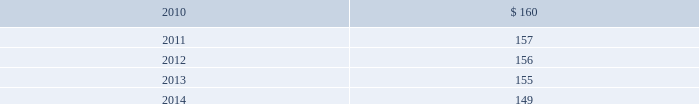Blackrock n 96 n notes in april 2009 , the company acquired $ 2 million of finite- lived management contracts with a five-year estimated useful life associated with the acquisition of the r3 capital partners funds .
In december 2009 , in conjunction with the bgi trans- action , the company acquired $ 163 million of finite- lived management contracts with a weighted-average estimated useful life of approximately 10 years .
Estimated amortization expense for finite-lived intangible assets for each of the five succeeding years is as follows : ( dollar amounts in millions ) .
Indefinite-lived acquired management contracts on september 29 , 2006 , in conjunction with the mlim transaction , the company acquired indefinite-lived man- agement contracts valued at $ 4477 million consisting of $ 4271 million for all retail mutual funds and $ 206 million for alternative investment products .
On october 1 , 2007 , in conjunction with the quellos transaction , the company acquired $ 631 million in indefinite-lived management contracts associated with alternative investment products .
On october 1 , 2007 , the company purchased the remain- ing 20% ( 20 % ) of an investment manager of a fund of hedge funds .
In conjunction with this transaction , the company recorded $ 8 million in additional indefinite-lived management contracts associated with alternative investment products .
On december 1 , 2009 , in conjunction with the bgi transaction , the company acquired $ 9785 million in indefinite-lived management contracts valued consisting primarily for exchange traded funds and common and collective trusts .
Indefinite-lived acquired trade names/trademarks on december 1 , 2009 , in conjunction with the bgi transaction , the company acquired trade names/ trademarks primarily related to ishares valued at $ 1402.5 million .
The fair value was determined using a royalty rate based primarily on normalized marketing and promotion expenditures to develop and support the brands globally .
13 .
Borrowings short-term borrowings 2007 facility in august 2007 , the company entered into a five-year $ 2.5 billion unsecured revolving credit facility ( the 201c2007 facility 201d ) , which permits the company to request an additional $ 500 million of borrowing capacity , subject to lender credit approval , up to a maximum of $ 3.0 billion .
The 2007 facility requires the company not to exceed a maximum leverage ratio ( ratio of net debt to earnings before interest , taxes , depreciation and amortiza- tion , where net debt equals total debt less domestic unrestricted cash ) of 3 to 1 , which was satisfied with a ratio of less than 1 to 1 at december 31 , 2009 .
The 2007 facility provides back-up liquidity , funds ongoing working capital for general corporate purposes and funds various investment opportunities .
At december 31 , 2009 , the company had $ 200 million outstanding under the 2007 facility with an interest rate of 0.44% ( 0.44 % ) and a maturity date during february 2010 .
During february 2010 , the company rolled over $ 100 million in borrowings with an interest rate of 0.43% ( 0.43 % ) and a maturity date in may 2010 .
Lehman commercial paper inc .
Has a $ 140 million participation under the 2007 facility ; however blackrock does not expect that lehman commercial paper inc .
Will honor its commitment to fund additional amounts .
Bank of america , a related party , has a $ 140 million participation under the 2007 facility .
In december 2007 , in order to support two enhanced cash funds that blackrock manages , blackrock elected to procure two letters of credit under the existing 2007 facility in an aggregate amount of $ 100 million .
In decem- ber 2008 , the letters of credit were terminated .
Commercial paper program on october 14 , 2009 , blackrock established a com- mercial paper program ( the 201ccp program 201d ) under which the company may issue unsecured commercial paper notes ( the 201ccp notes 201d ) on a private placement basis up to a maximum aggregate amount outstanding at any time of $ 3 billion .
The proceeds of the commercial paper issuances were used for the financing of a portion of the bgi transaction .
Subsidiaries of bank of america and barclays , as well as other third parties , act as dealers under the cp program .
The cp program is supported by the 2007 facility .
The company began issuance of cp notes under the cp program on november 4 , 2009 .
As of december 31 , 2009 , blackrock had approximately $ 2 billion of out- standing cp notes with a weighted average interest rate of 0.20% ( 0.20 % ) and a weighted average maturity of 23 days .
Since december 31 , 2009 , the company repaid approxi- mately $ 1.4 billion of cp notes with proceeds from the long-term notes issued in december 2009 .
As of march 5 , 2010 , blackrock had $ 596 million of outstanding cp notes with a weighted average interest rate of 0.18% ( 0.18 % ) and a weighted average maturity of 38 days .
Japan commitment-line in june 2008 , blackrock japan co. , ltd. , a wholly owned subsidiary of the company , entered into a five billion japanese yen commitment-line agreement with a bank- ing institution ( the 201cjapan commitment-line 201d ) .
The term of the japan commitment-line was one year and interest accrued at the applicable japanese short-term prime rate .
In june 2009 , blackrock japan co. , ltd .
Renewed the japan commitment-line for a term of one year .
The japan commitment-line is intended to provide liquid- ity and flexibility for operating requirements in japan .
At december 31 , 2009 , the company had no borrowings outstanding on the japan commitment-line .
Convertible debentures in february 2005 , the company issued $ 250 million aggregate principal amount of convertible debentures ( the 201cdebentures 201d ) , due in 2035 and bearing interest at a rate of 2.625% ( 2.625 % ) per annum .
Interest is payable semi- annually in arrears on february 15 and august 15 of each year , and commenced august 15 , 2005 .
Prior to february 15 , 2009 , the debentures could have been convertible at the option of the holder at a decem- ber 31 , 2008 conversion rate of 9.9639 shares of common stock per one dollar principal amount of debentures under certain circumstances .
The debentures would have been convertible into cash and , in some situations as described below , additional shares of the company 2019s common stock , if during the five business day period after any five consecutive trading day period the trading price per debenture for each day of such period is less than 103% ( 103 % ) of the product of the last reported sales price of blackrock 2019s common stock and the conversion rate of the debentures on each such day or upon the occurrence of certain other corporate events , such as a distribution to the holders of blackrock common stock of certain rights , assets or debt securities , if the company becomes party to a merger , consolidation or transfer of all or substantially all of its assets or a change of control of the company .
On february 15 , 2009 , the debentures became convertible into cash at any time prior to maturity at the option of the holder and , in some situations as described below , additional shares of the company 2019s common stock at the current conversion rate .
At the time the debentures are tendered for conver- sion , for each one dollar principal amount of debentures converted , a holder shall be entitled to receive cash and shares of blackrock common stock , if any , the aggregate value of which ( the 201cconversion value 201d ) will be deter- mined by multiplying the applicable conversion rate by the average of the daily volume weighted average price of blackrock common stock for each of the ten consecutive trading days beginning on the second trading day imme- diately following the day the debentures are tendered for conversion ( the 201cten-day weighted average price 201d ) .
The company will deliver the conversion value to holders as follows : ( 1 ) an amount in cash ( the 201cprincipal return 201d ) equal to the lesser of ( a ) the aggregate conversion value of the debentures to be converted and ( b ) the aggregate principal amount of the debentures to be converted , and ( 2 ) if the aggregate conversion value of the debentures to be converted is greater than the principal return , an amount in shares ( the 201cnet shares 201d ) , determined as set forth below , equal to such aggregate conversion value less the principal return ( the 201cnet share amount 201d ) .
The number of net shares to be paid will be determined by dividing the net share amount by the ten-day weighted average price .
In lieu of delivering fractional shares , the company will deliver cash based on the ten-day weighted average price .
The conversion rate for the debentures is subject to adjustments upon the occurrence of certain corporate events , such as a change of control of the company , 193253ti_txt.indd 96 4/2/10 1:18 pm .
What is the percent change in estimated amortization expense for finite-lived intangible assets from 2010 to 2011? 
Computations: ((160 - 157) / 157)
Answer: 0.01911. Blackrock n 96 n notes in april 2009 , the company acquired $ 2 million of finite- lived management contracts with a five-year estimated useful life associated with the acquisition of the r3 capital partners funds .
In december 2009 , in conjunction with the bgi trans- action , the company acquired $ 163 million of finite- lived management contracts with a weighted-average estimated useful life of approximately 10 years .
Estimated amortization expense for finite-lived intangible assets for each of the five succeeding years is as follows : ( dollar amounts in millions ) .
Indefinite-lived acquired management contracts on september 29 , 2006 , in conjunction with the mlim transaction , the company acquired indefinite-lived man- agement contracts valued at $ 4477 million consisting of $ 4271 million for all retail mutual funds and $ 206 million for alternative investment products .
On october 1 , 2007 , in conjunction with the quellos transaction , the company acquired $ 631 million in indefinite-lived management contracts associated with alternative investment products .
On october 1 , 2007 , the company purchased the remain- ing 20% ( 20 % ) of an investment manager of a fund of hedge funds .
In conjunction with this transaction , the company recorded $ 8 million in additional indefinite-lived management contracts associated with alternative investment products .
On december 1 , 2009 , in conjunction with the bgi transaction , the company acquired $ 9785 million in indefinite-lived management contracts valued consisting primarily for exchange traded funds and common and collective trusts .
Indefinite-lived acquired trade names/trademarks on december 1 , 2009 , in conjunction with the bgi transaction , the company acquired trade names/ trademarks primarily related to ishares valued at $ 1402.5 million .
The fair value was determined using a royalty rate based primarily on normalized marketing and promotion expenditures to develop and support the brands globally .
13 .
Borrowings short-term borrowings 2007 facility in august 2007 , the company entered into a five-year $ 2.5 billion unsecured revolving credit facility ( the 201c2007 facility 201d ) , which permits the company to request an additional $ 500 million of borrowing capacity , subject to lender credit approval , up to a maximum of $ 3.0 billion .
The 2007 facility requires the company not to exceed a maximum leverage ratio ( ratio of net debt to earnings before interest , taxes , depreciation and amortiza- tion , where net debt equals total debt less domestic unrestricted cash ) of 3 to 1 , which was satisfied with a ratio of less than 1 to 1 at december 31 , 2009 .
The 2007 facility provides back-up liquidity , funds ongoing working capital for general corporate purposes and funds various investment opportunities .
At december 31 , 2009 , the company had $ 200 million outstanding under the 2007 facility with an interest rate of 0.44% ( 0.44 % ) and a maturity date during february 2010 .
During february 2010 , the company rolled over $ 100 million in borrowings with an interest rate of 0.43% ( 0.43 % ) and a maturity date in may 2010 .
Lehman commercial paper inc .
Has a $ 140 million participation under the 2007 facility ; however blackrock does not expect that lehman commercial paper inc .
Will honor its commitment to fund additional amounts .
Bank of america , a related party , has a $ 140 million participation under the 2007 facility .
In december 2007 , in order to support two enhanced cash funds that blackrock manages , blackrock elected to procure two letters of credit under the existing 2007 facility in an aggregate amount of $ 100 million .
In decem- ber 2008 , the letters of credit were terminated .
Commercial paper program on october 14 , 2009 , blackrock established a com- mercial paper program ( the 201ccp program 201d ) under which the company may issue unsecured commercial paper notes ( the 201ccp notes 201d ) on a private placement basis up to a maximum aggregate amount outstanding at any time of $ 3 billion .
The proceeds of the commercial paper issuances were used for the financing of a portion of the bgi transaction .
Subsidiaries of bank of america and barclays , as well as other third parties , act as dealers under the cp program .
The cp program is supported by the 2007 facility .
The company began issuance of cp notes under the cp program on november 4 , 2009 .
As of december 31 , 2009 , blackrock had approximately $ 2 billion of out- standing cp notes with a weighted average interest rate of 0.20% ( 0.20 % ) and a weighted average maturity of 23 days .
Since december 31 , 2009 , the company repaid approxi- mately $ 1.4 billion of cp notes with proceeds from the long-term notes issued in december 2009 .
As of march 5 , 2010 , blackrock had $ 596 million of outstanding cp notes with a weighted average interest rate of 0.18% ( 0.18 % ) and a weighted average maturity of 38 days .
Japan commitment-line in june 2008 , blackrock japan co. , ltd. , a wholly owned subsidiary of the company , entered into a five billion japanese yen commitment-line agreement with a bank- ing institution ( the 201cjapan commitment-line 201d ) .
The term of the japan commitment-line was one year and interest accrued at the applicable japanese short-term prime rate .
In june 2009 , blackrock japan co. , ltd .
Renewed the japan commitment-line for a term of one year .
The japan commitment-line is intended to provide liquid- ity and flexibility for operating requirements in japan .
At december 31 , 2009 , the company had no borrowings outstanding on the japan commitment-line .
Convertible debentures in february 2005 , the company issued $ 250 million aggregate principal amount of convertible debentures ( the 201cdebentures 201d ) , due in 2035 and bearing interest at a rate of 2.625% ( 2.625 % ) per annum .
Interest is payable semi- annually in arrears on february 15 and august 15 of each year , and commenced august 15 , 2005 .
Prior to february 15 , 2009 , the debentures could have been convertible at the option of the holder at a decem- ber 31 , 2008 conversion rate of 9.9639 shares of common stock per one dollar principal amount of debentures under certain circumstances .
The debentures would have been convertible into cash and , in some situations as described below , additional shares of the company 2019s common stock , if during the five business day period after any five consecutive trading day period the trading price per debenture for each day of such period is less than 103% ( 103 % ) of the product of the last reported sales price of blackrock 2019s common stock and the conversion rate of the debentures on each such day or upon the occurrence of certain other corporate events , such as a distribution to the holders of blackrock common stock of certain rights , assets or debt securities , if the company becomes party to a merger , consolidation or transfer of all or substantially all of its assets or a change of control of the company .
On february 15 , 2009 , the debentures became convertible into cash at any time prior to maturity at the option of the holder and , in some situations as described below , additional shares of the company 2019s common stock at the current conversion rate .
At the time the debentures are tendered for conver- sion , for each one dollar principal amount of debentures converted , a holder shall be entitled to receive cash and shares of blackrock common stock , if any , the aggregate value of which ( the 201cconversion value 201d ) will be deter- mined by multiplying the applicable conversion rate by the average of the daily volume weighted average price of blackrock common stock for each of the ten consecutive trading days beginning on the second trading day imme- diately following the day the debentures are tendered for conversion ( the 201cten-day weighted average price 201d ) .
The company will deliver the conversion value to holders as follows : ( 1 ) an amount in cash ( the 201cprincipal return 201d ) equal to the lesser of ( a ) the aggregate conversion value of the debentures to be converted and ( b ) the aggregate principal amount of the debentures to be converted , and ( 2 ) if the aggregate conversion value of the debentures to be converted is greater than the principal return , an amount in shares ( the 201cnet shares 201d ) , determined as set forth below , equal to such aggregate conversion value less the principal return ( the 201cnet share amount 201d ) .
The number of net shares to be paid will be determined by dividing the net share amount by the ten-day weighted average price .
In lieu of delivering fractional shares , the company will deliver cash based on the ten-day weighted average price .
The conversion rate for the debentures is subject to adjustments upon the occurrence of certain corporate events , such as a change of control of the company , 193253ti_txt.indd 96 4/2/10 1:18 pm .
What is the annual interest expense related to debentures issued in 2005 that are due in 2035 , in millions? 
Computations: (250 * 2.625%)
Answer: 6.5625. 